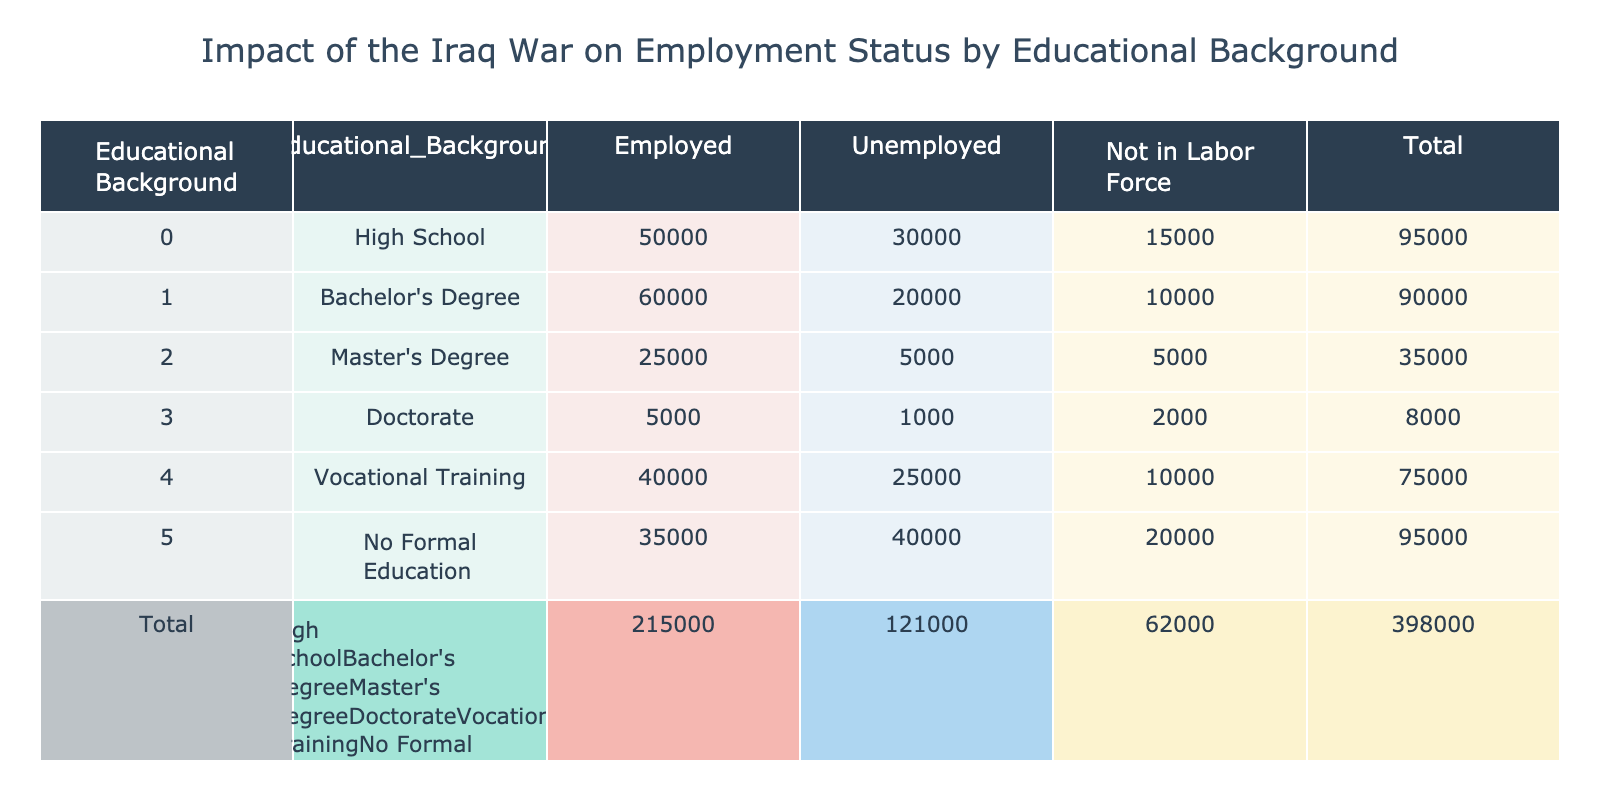What is the total number of people who are employed with a Master's Degree? According to the data, there are 25,000 individuals with a Master's Degree who are employed.
Answer: 25000 How many people are unemployed with a Doctorate? The table indicates that there are 1,000 people who hold a Doctorate and are unemployed.
Answer: 1000 What is the total number of individuals who have No Formal Education? By summing the values for No Formal Education, we find that the total (employed + unemployed + not in labor force) is 35,000 + 40,000 + 20,000 = 95,000.
Answer: 95000 Which educational background has the highest number of unemployed individuals? Looking through the unemployment figures, No Formal Education has 40,000 unemployed individuals, which is higher than any other educational background listed.
Answer: No Formal Education What is the difference in the number of unemployed individuals between those with a Bachelor's Degree and those with a Master's Degree? The number of unemployed individuals with a Bachelor's Degree is 20,000, while for a Master's Degree, it is 5,000. The difference is 20,000 - 5,000 = 15,000.
Answer: 15000 Is it true that individuals with Vocational Training are more likely to be employed than those with a Bachelor's Degree? Checking the data, there are 40,000 employed with Vocational Training and 60,000 with a Bachelor's Degree; thus, it is false that Vocational Training individuals are more likely to be employed than Bachelor's Degree holders.
Answer: No What percentage of individuals with a High School education are not in the labor force? With 15,000 not in the labor force out of a total of 95,000 with a High School education (50,000 employed + 30,000 unemployed + 15,000 not in labor force), the percentage can be calculated as (15,000 / 95,000) * 100 = 15.79%.
Answer: 15.79% How many more people are not in the labor force when compared to the unemployed individuals with No Formal Education? The number not in the labor force for No Formal Education is 20,000, and the unemployed is 40,000. The difference is 20,000 - 40,000 = -20,000, indicating there are 20,000 more unemployed.
Answer: 20000 Is there a higher number of employed individuals with a Bachelor's Degree or those with Vocational Training? The table shows 60,000 employed with a Bachelor's Degree and 40,000 with Vocational Training, so it is true that there are more employed individuals with a Bachelor's Degree.
Answer: Yes 